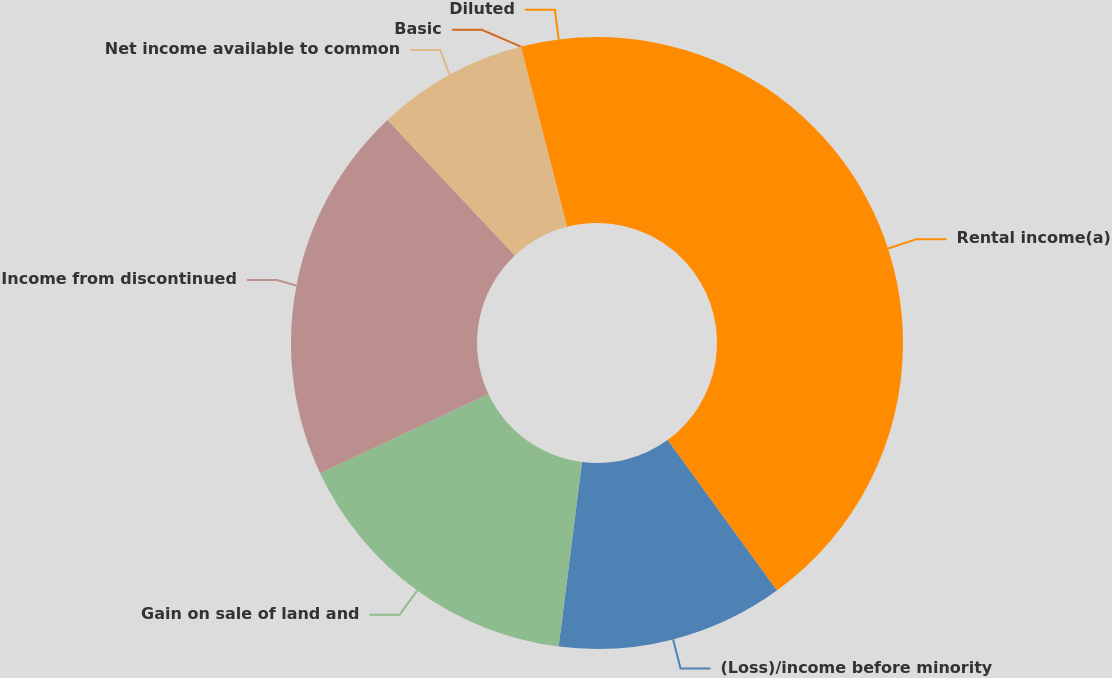<chart> <loc_0><loc_0><loc_500><loc_500><pie_chart><fcel>Rental income(a)<fcel>(Loss)/income before minority<fcel>Gain on sale of land and<fcel>Income from discontinued<fcel>Net income available to common<fcel>Basic<fcel>Diluted<nl><fcel>40.0%<fcel>12.0%<fcel>16.0%<fcel>20.0%<fcel>8.0%<fcel>0.0%<fcel>4.0%<nl></chart> 